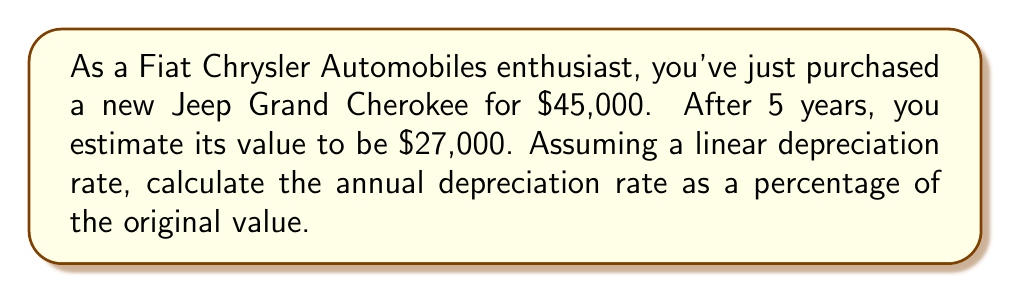Help me with this question. To solve this problem, we'll use the linear depreciation formula and follow these steps:

1. Calculate the total depreciation:
   Total depreciation = Original value - Value after 5 years
   $$ \text{Total depreciation} = \$45,000 - \$27,000 = \$18,000 $$

2. Calculate the annual depreciation:
   Annual depreciation = Total depreciation ÷ Number of years
   $$ \text{Annual depreciation} = \$18,000 \div 5 = \$3,600 \text{ per year} $$

3. Calculate the annual depreciation rate as a percentage:
   Annual depreciation rate = (Annual depreciation ÷ Original value) × 100
   $$ \text{Annual depreciation rate} = \frac{\$3,600}{\$45,000} \times 100 = 8\% $$

Therefore, the Jeep Grand Cherokee depreciates at a rate of 8% of its original value per year.
Answer: The annual depreciation rate of the Jeep Grand Cherokee is 8% of its original value. 